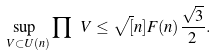Convert formula to latex. <formula><loc_0><loc_0><loc_500><loc_500>\sup _ { \ V \subset U ( n ) } \prod \ V \leq \sqrt { [ } n ] { F ( n ) } \frac { \sqrt { 3 } } { 2 } .</formula> 